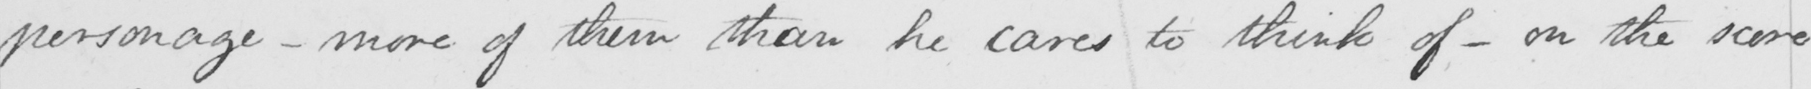Please provide the text content of this handwritten line. personage  _  more of them than he cares to think of  _  on the score 